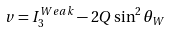Convert formula to latex. <formula><loc_0><loc_0><loc_500><loc_500>v = I _ { 3 } ^ { W e a k } - 2 Q \sin ^ { 2 } \theta _ { W }</formula> 